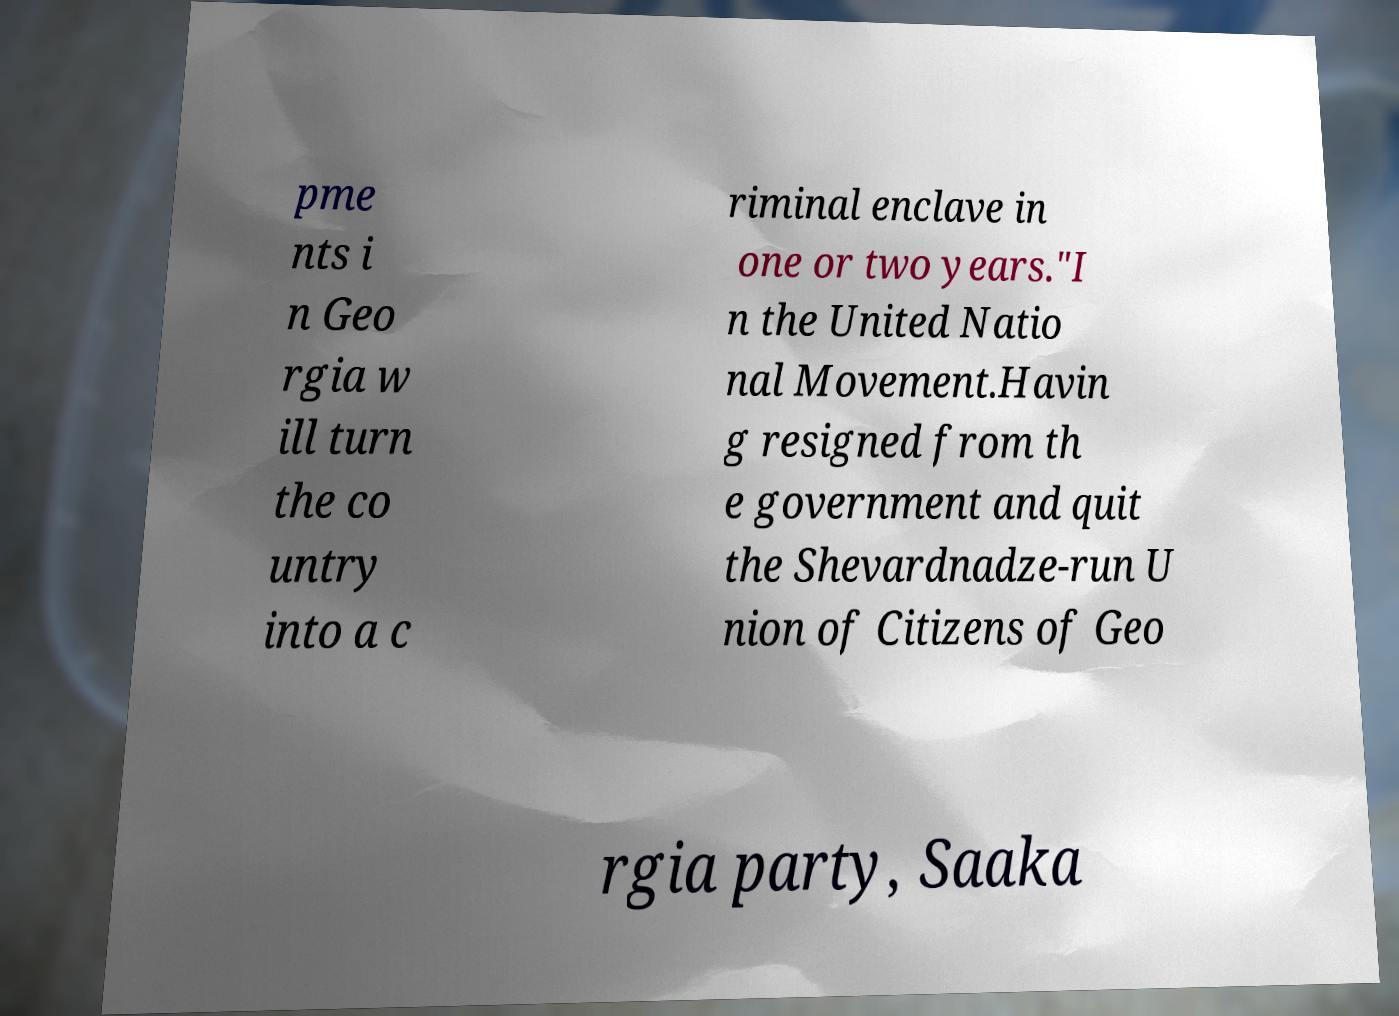Could you extract and type out the text from this image? pme nts i n Geo rgia w ill turn the co untry into a c riminal enclave in one or two years."I n the United Natio nal Movement.Havin g resigned from th e government and quit the Shevardnadze-run U nion of Citizens of Geo rgia party, Saaka 